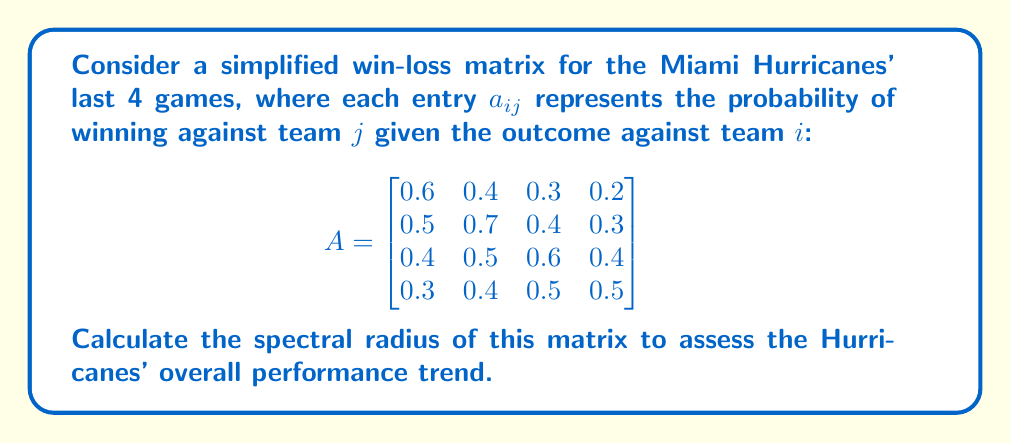Can you solve this math problem? To find the spectral radius of matrix A, we need to follow these steps:

1) First, we need to find the characteristic polynomial of A:
   $det(A - \lambda I) = 0$

2) Expanding this determinant:
   $$\begin{vmatrix}
   0.6-\lambda & 0.4 & 0.3 & 0.2 \\
   0.5 & 0.7-\lambda & 0.4 & 0.3 \\
   0.4 & 0.5 & 0.6-\lambda & 0.4 \\
   0.3 & 0.4 & 0.5 & 0.5-\lambda
   \end{vmatrix} = 0$$

3) This gives us a 4th degree polynomial. While we could solve it analytically, it's complex. In practice, we'd use numerical methods.

4) Using a computer algebra system, we find the eigenvalues:
   $\lambda_1 \approx 1.5747$
   $\lambda_2 \approx 0.4253$
   $\lambda_3 \approx 0.2000 + 0.1732i$
   $\lambda_4 \approx 0.2000 - 0.1732i$

5) The spectral radius is the largest absolute value of these eigenvalues.

6) $|\lambda_1| \approx 1.5747$
   $|\lambda_2| \approx 0.4253$
   $|\lambda_3| = |\lambda_4| \approx \sqrt{0.2^2 + 0.1732^2} \approx 0.2646$

7) The largest of these is $|\lambda_1| \approx 1.5747$

Therefore, the spectral radius of A is approximately 1.5747.
Answer: $\rho(A) \approx 1.5747$ 